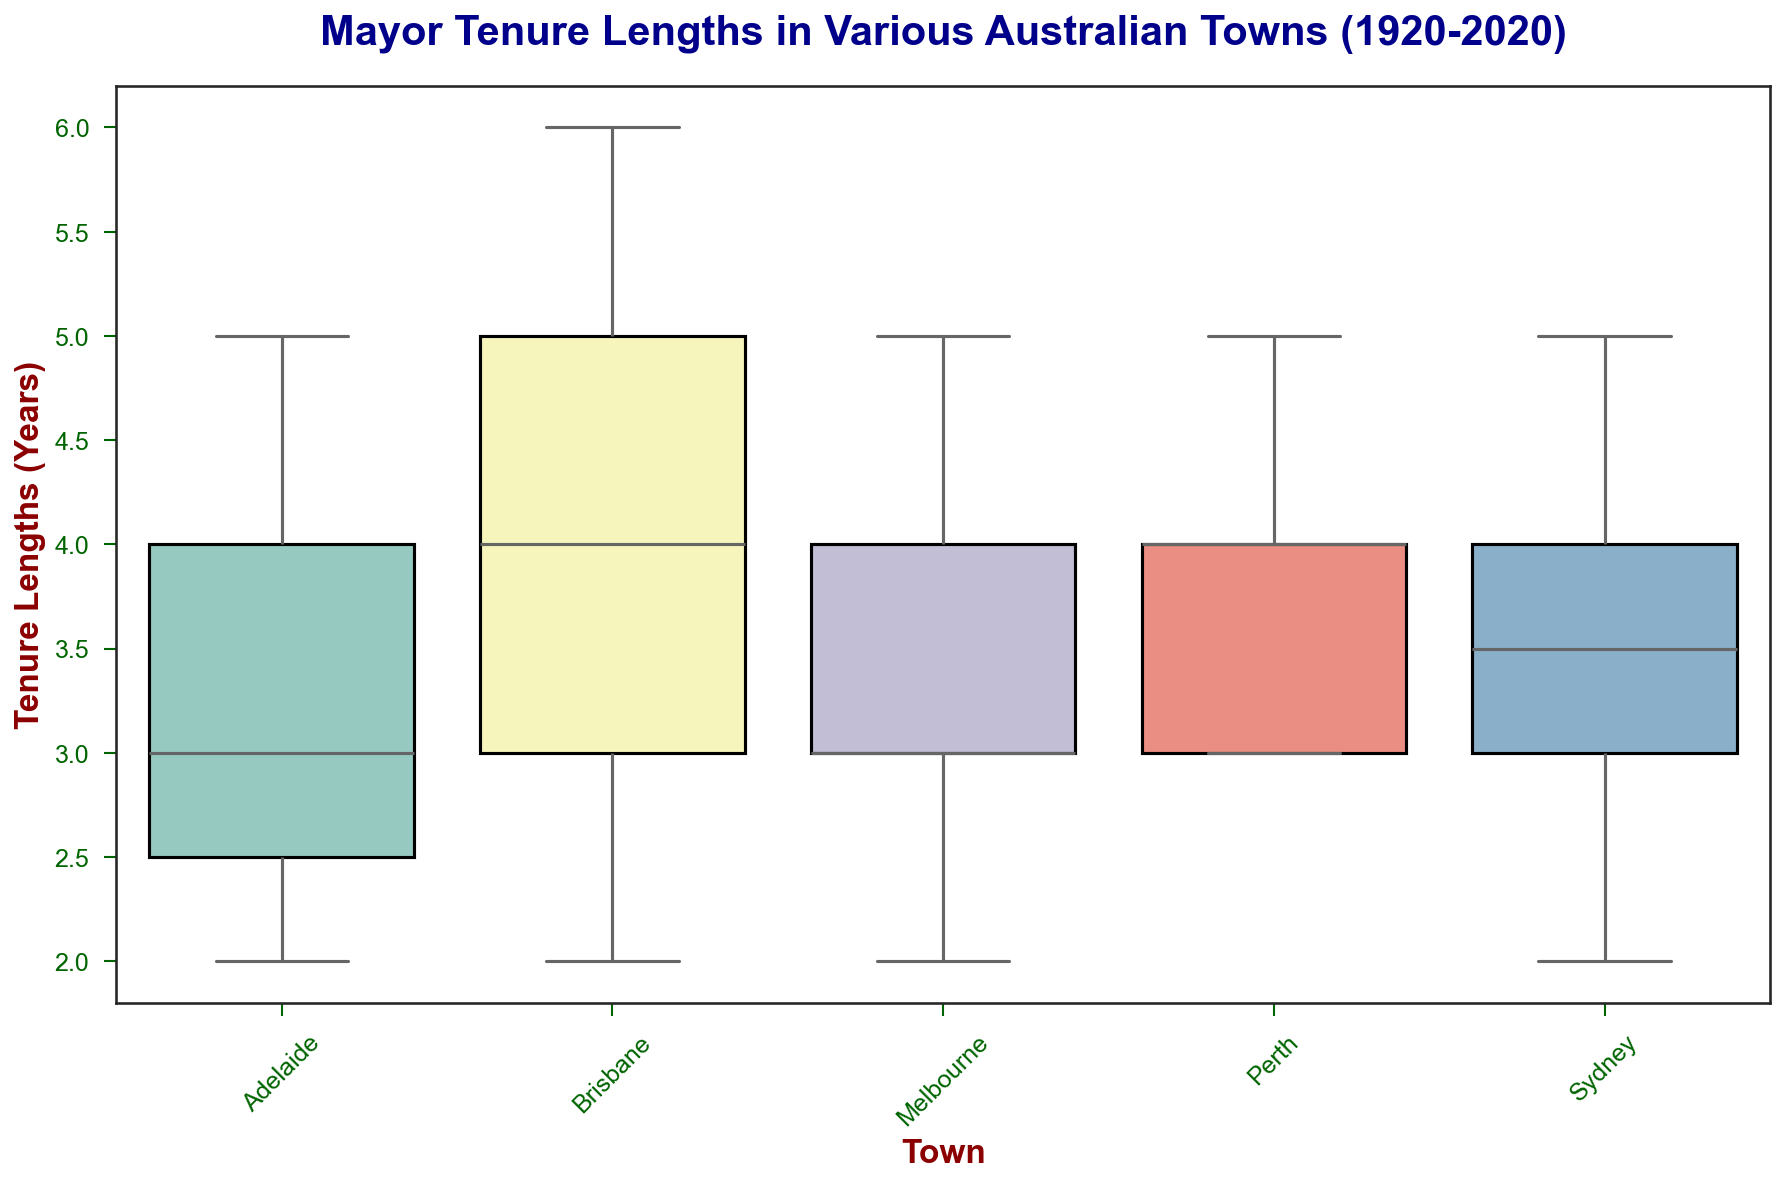What is the median value of mayoral tenure in Brisbane? To find the median value of mayoral tenure in Brisbane, one would observe the central line inside the box for Brisbane. The box represents the interquartile range, and the line inside represents the median.
Answer: 4 Which town shows the highest overall mayoral tenures (i.e., the town with the longest whisker length on the upper side)? Examine the upper whiskers of the box plots for each town. The town with the longest upper whisker length represents the highest maximum mayoral tenures.
Answer: Brisbane What is the interquartile range (IQR) for mayoral tenures in Melbourne? To determine the IQR, observe the length of the box for Melbourne. The IQR is the distance between the first quartile (bottom edge of the box) and the third quartile (top edge of the box).
Answer: 2 Which town has the lowest minimum mayoral tenure? Look at the lower whiskers for each town. The town with the shortest lower whisker represents the lowest minimum mayoral tenure.
Answer: Adelaide Compare the median mayoral tenure lengths between Sydney and Perth. Observe the position of the median lines inside the boxes for Sydney and Perth. Compare the heights of these lines to determine which has the higher median.
Answer: Sydney Which town has the most consistent (least spread) tenure lengths? The town with the smallest overall box (shortest height from the lowest to the highest whisker) indicates the least variability in tenure lengths.
Answer: Melbourne Do any towns show outlier values in mayoral tenure lengths? Look for any points that lie separately from the box plot whiskers. These points indicate outliers.
Answer: No Which town has a higher maximum mayoral tenure: Adelaide or Brisbane? Compare the top whisker lengths of the boxes for Adelaide and Brisbane. The longer one indicates a higher maximum tenure.
Answer: Brisbane Which town has the widest range of mayoral tenures? Compare the total height from the bottom whisker to the top whisker across all towns. The tallest overall height indicates the widest range.
Answer: Brisbane 